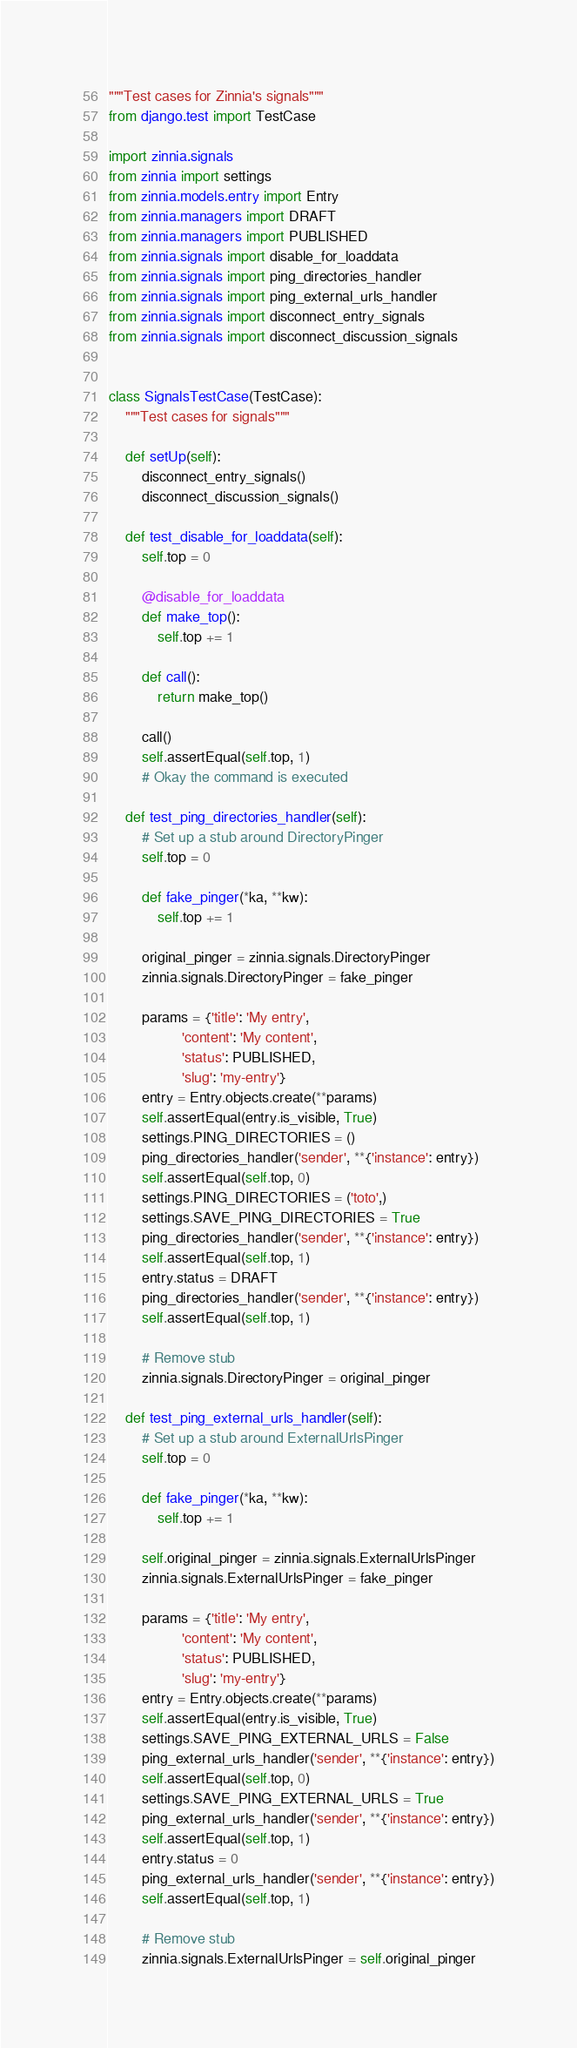<code> <loc_0><loc_0><loc_500><loc_500><_Python_>"""Test cases for Zinnia's signals"""
from django.test import TestCase

import zinnia.signals
from zinnia import settings
from zinnia.models.entry import Entry
from zinnia.managers import DRAFT
from zinnia.managers import PUBLISHED
from zinnia.signals import disable_for_loaddata
from zinnia.signals import ping_directories_handler
from zinnia.signals import ping_external_urls_handler
from zinnia.signals import disconnect_entry_signals
from zinnia.signals import disconnect_discussion_signals


class SignalsTestCase(TestCase):
    """Test cases for signals"""

    def setUp(self):
        disconnect_entry_signals()
        disconnect_discussion_signals()

    def test_disable_for_loaddata(self):
        self.top = 0

        @disable_for_loaddata
        def make_top():
            self.top += 1

        def call():
            return make_top()

        call()
        self.assertEqual(self.top, 1)
        # Okay the command is executed

    def test_ping_directories_handler(self):
        # Set up a stub around DirectoryPinger
        self.top = 0

        def fake_pinger(*ka, **kw):
            self.top += 1

        original_pinger = zinnia.signals.DirectoryPinger
        zinnia.signals.DirectoryPinger = fake_pinger

        params = {'title': 'My entry',
                  'content': 'My content',
                  'status': PUBLISHED,
                  'slug': 'my-entry'}
        entry = Entry.objects.create(**params)
        self.assertEqual(entry.is_visible, True)
        settings.PING_DIRECTORIES = ()
        ping_directories_handler('sender', **{'instance': entry})
        self.assertEqual(self.top, 0)
        settings.PING_DIRECTORIES = ('toto',)
        settings.SAVE_PING_DIRECTORIES = True
        ping_directories_handler('sender', **{'instance': entry})
        self.assertEqual(self.top, 1)
        entry.status = DRAFT
        ping_directories_handler('sender', **{'instance': entry})
        self.assertEqual(self.top, 1)

        # Remove stub
        zinnia.signals.DirectoryPinger = original_pinger

    def test_ping_external_urls_handler(self):
        # Set up a stub around ExternalUrlsPinger
        self.top = 0

        def fake_pinger(*ka, **kw):
            self.top += 1

        self.original_pinger = zinnia.signals.ExternalUrlsPinger
        zinnia.signals.ExternalUrlsPinger = fake_pinger

        params = {'title': 'My entry',
                  'content': 'My content',
                  'status': PUBLISHED,
                  'slug': 'my-entry'}
        entry = Entry.objects.create(**params)
        self.assertEqual(entry.is_visible, True)
        settings.SAVE_PING_EXTERNAL_URLS = False
        ping_external_urls_handler('sender', **{'instance': entry})
        self.assertEqual(self.top, 0)
        settings.SAVE_PING_EXTERNAL_URLS = True
        ping_external_urls_handler('sender', **{'instance': entry})
        self.assertEqual(self.top, 1)
        entry.status = 0
        ping_external_urls_handler('sender', **{'instance': entry})
        self.assertEqual(self.top, 1)

        # Remove stub
        zinnia.signals.ExternalUrlsPinger = self.original_pinger
</code> 